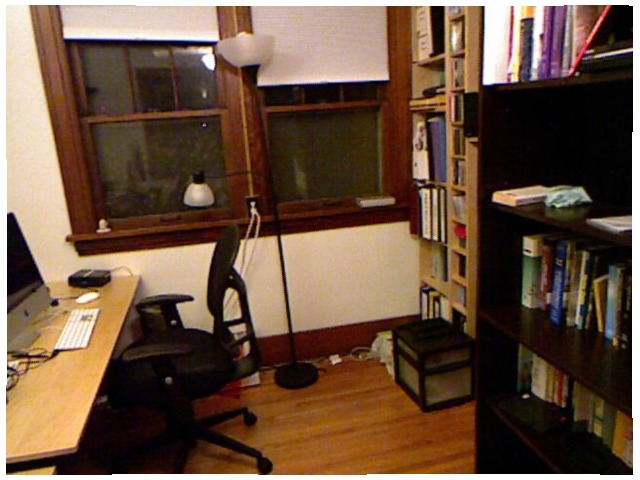<image>
Is the lamp on the desk? No. The lamp is not positioned on the desk. They may be near each other, but the lamp is not supported by or resting on top of the desk. Is there a light behind the window? No. The light is not behind the window. From this viewpoint, the light appears to be positioned elsewhere in the scene. Is the light above the chair? No. The light is not positioned above the chair. The vertical arrangement shows a different relationship. 